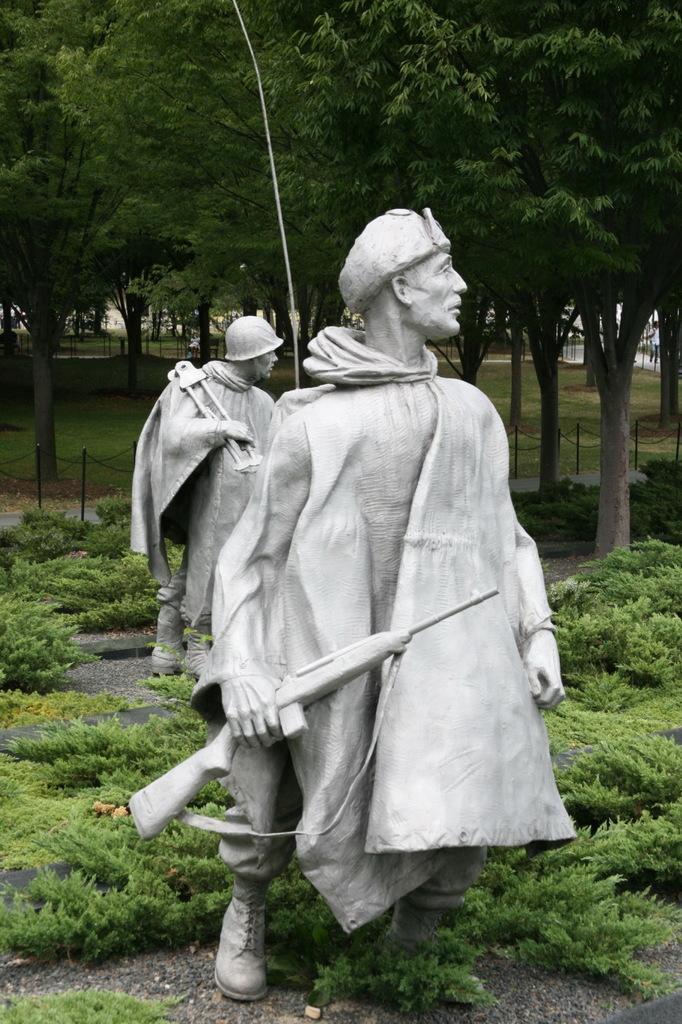Please provide a concise description of this image. In the foreground of this image, there are statues around which, there are plants. In the background, there are trees. 